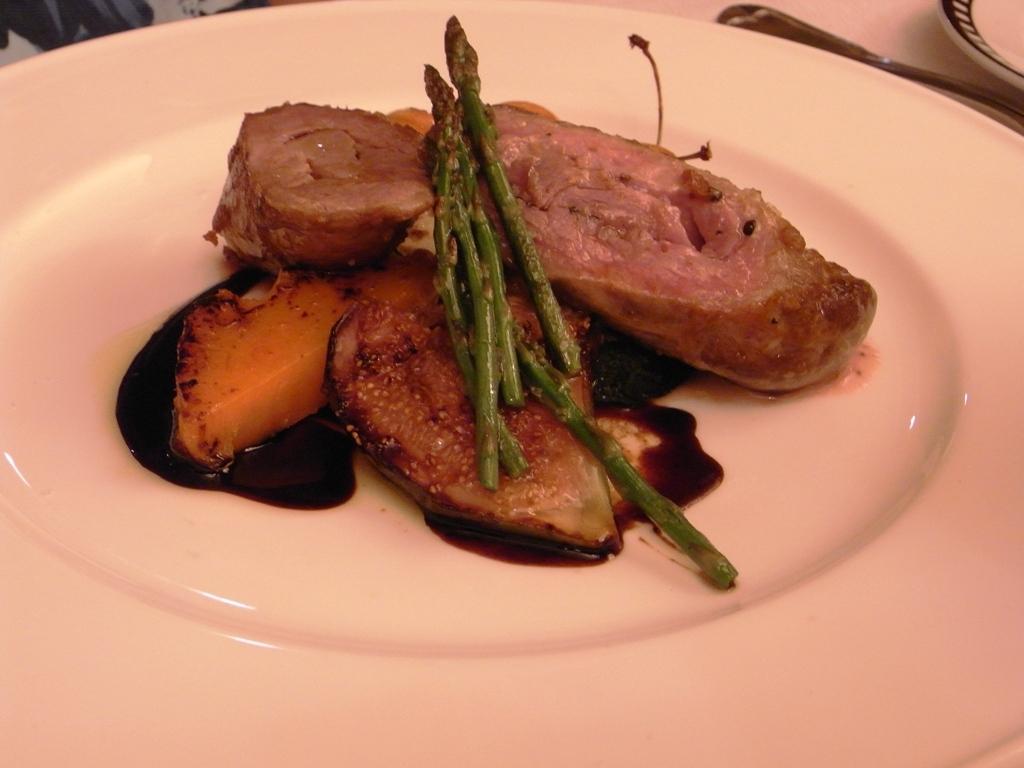Describe this image in one or two sentences. In this image there are plates, food and object. 